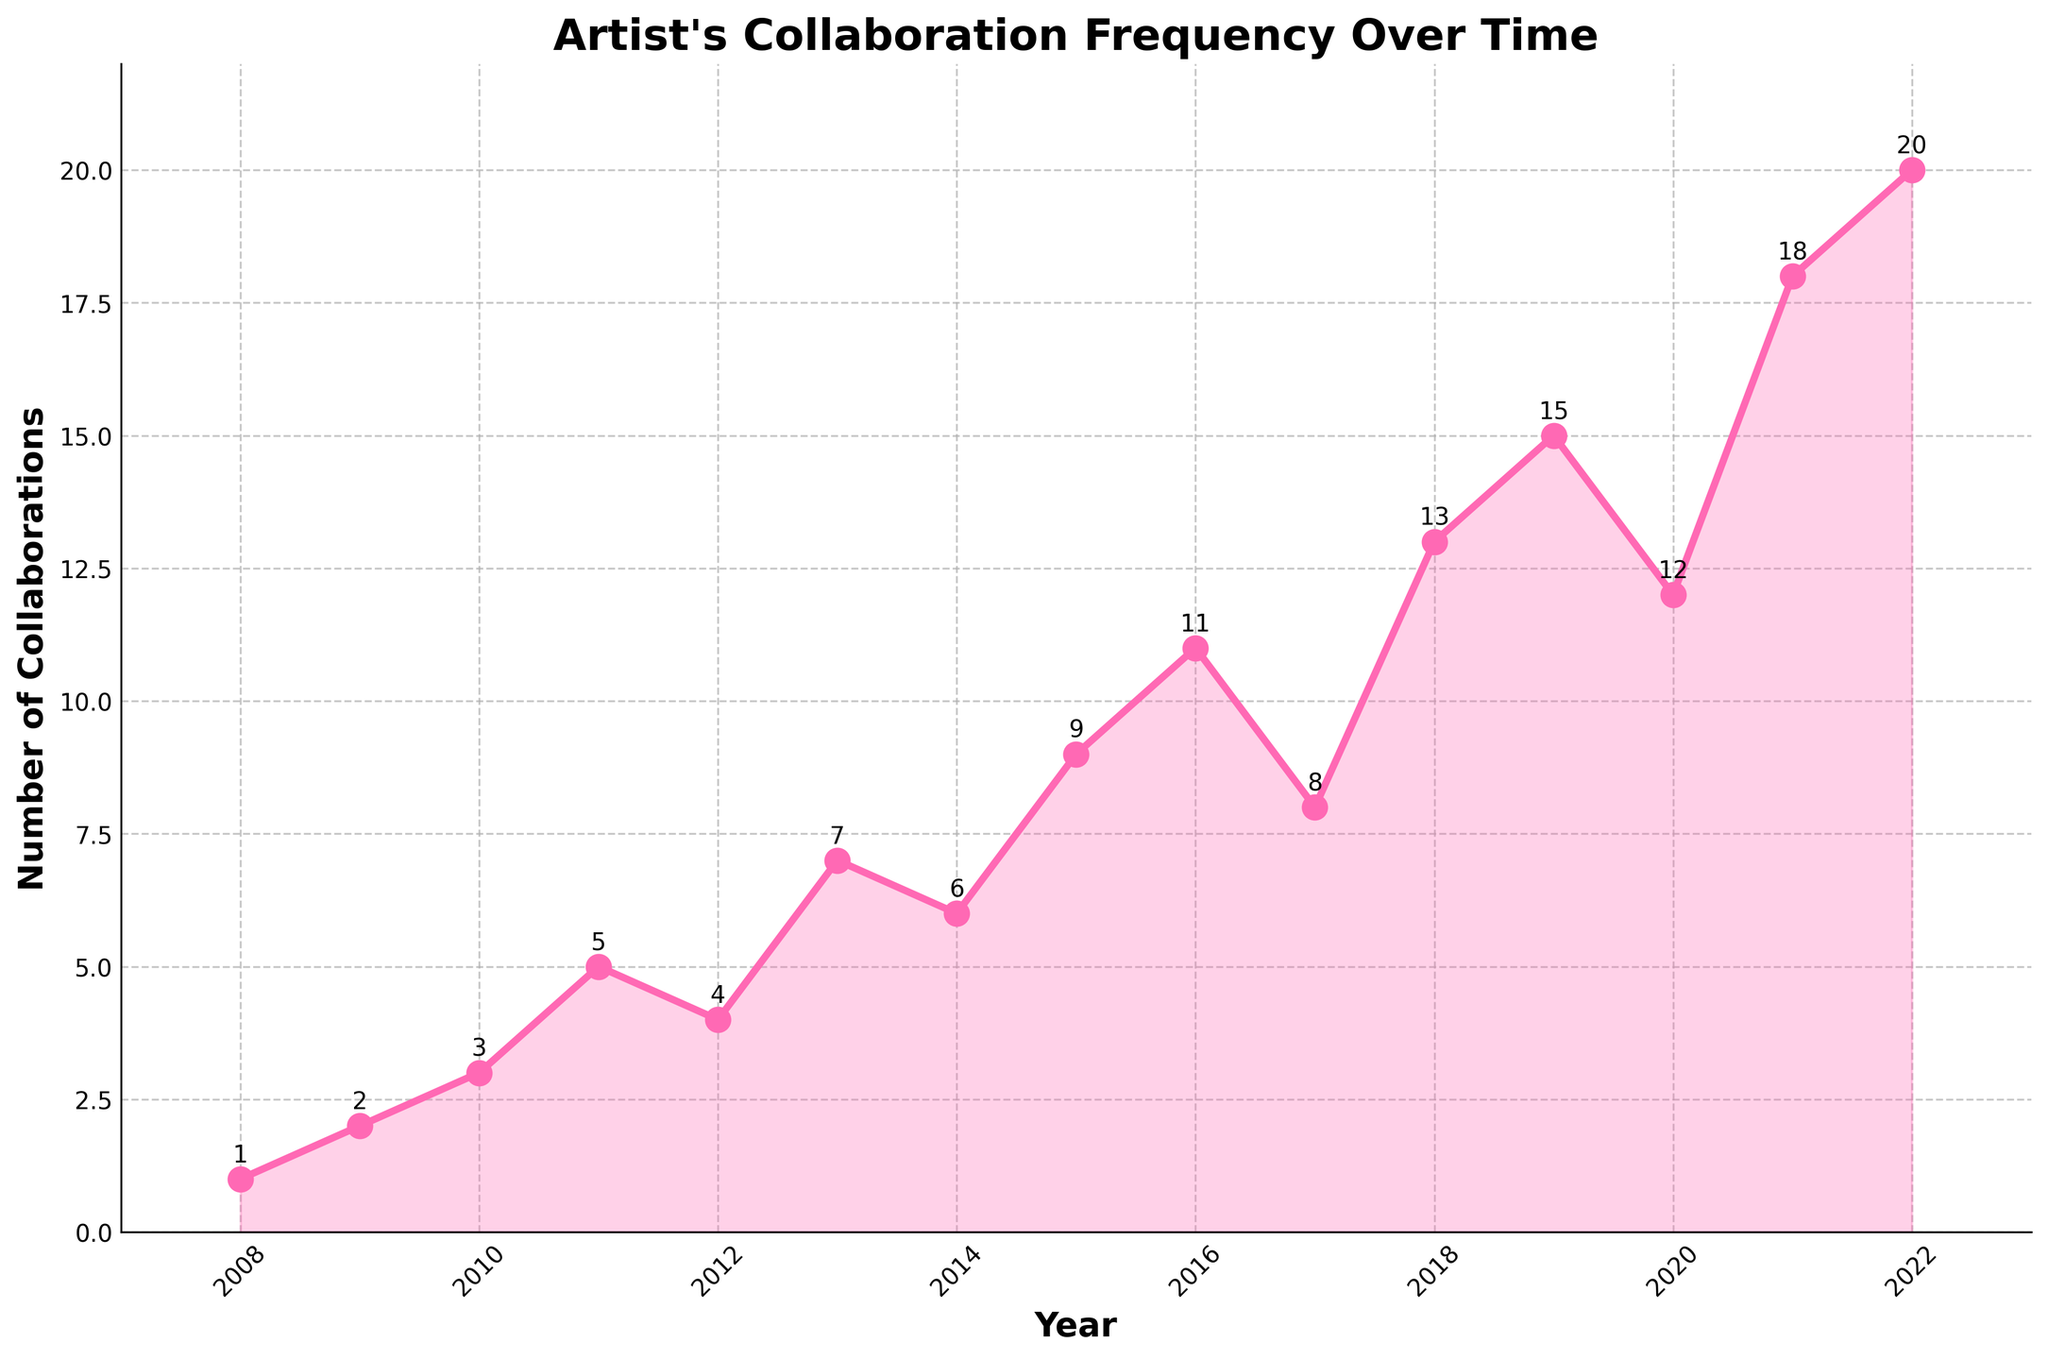What is the highest number of collaborations in a single year? The highest number can be identified by looking at the peaks in the data series. The data point for 2022 shows the highest value.
Answer: 20 During which year did the artist's collaborations first exceed 10? Find the first year where the number of collaborations is greater than 10 by checking the y-values of each year. The chart shows it happened in 2016.
Answer: 2016 What is the difference in the number of collaborations between 2010 and 2015? Look at the data points for 2010 and 2015; 2010 has 3 and 2015 has 9. Calculate the difference. 9 - 3 = 6.
Answer: 6 How does the number of collaborations in 2016 compare to that in 2017? Compare the values of the data series for these years. In 2016, the value is 11, and in 2017, it is 8.
Answer: 2016 has more Which year shows the least number of collaborations and how many? The minimum can be found by identifying the lowest point in the series, which is in 2008 with 1 collaboration.
Answer: 2008, 1 What is the average number of collaborations per year from 2019 to 2022? Find the data for each year: 2019(15), 2020(12), 2021(18), and 2022(20). Sum them up and divide by 4. (15+12+18+20)/4 = 65/4 = 16.25
Answer: 16.25 In which year did the artist see the largest increase in collaborations compared to the previous year? Calculate the year-over-year differences and identify the maximum increase. The largest increase is from 2020 to 2021 (18 - 12 = 6).
Answer: 2021 How many times did the number of collaborations decrease from one year to the next? Check the plots where the line decreases between consecutive years: 2012 to 2013, 2017 to 2018, 2019 to 2020.
Answer: 3 times Is there any year between 2008 and 2012 where the number of collaborations was the same as the previous year? Examine the plots for consecutive years 2008 to 2012 for any same values; there are none.
Answer: No What is the total number of collaborations from 2008 to 2012? Sum up the values for 2008 (1), 2009 (2), 2010 (3), 2011 (5), and 2012 (4). 1+2+3+5+4 = 15.
Answer: 15 